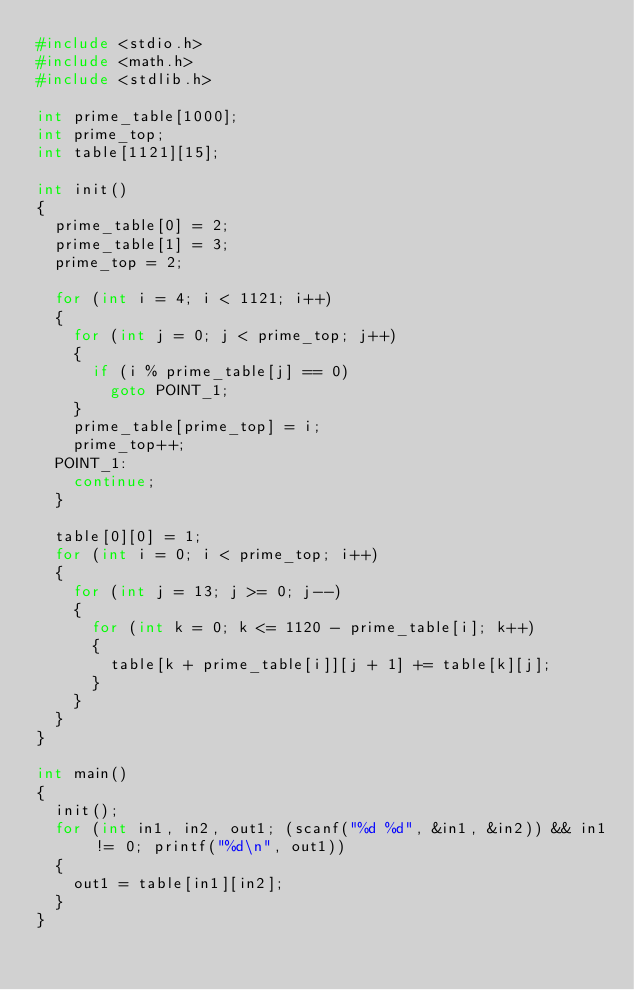Convert code to text. <code><loc_0><loc_0><loc_500><loc_500><_C_>#include <stdio.h>
#include <math.h>
#include <stdlib.h>

int prime_table[1000];
int prime_top;
int table[1121][15];

int init()
{
	prime_table[0] = 2;
	prime_table[1] = 3;
	prime_top = 2;

	for (int i = 4; i < 1121; i++)
	{
		for (int j = 0; j < prime_top; j++)
		{
			if (i % prime_table[j] == 0)
				goto POINT_1;
		}
		prime_table[prime_top] = i;
		prime_top++;
	POINT_1:
		continue;
	}

	table[0][0] = 1;
	for (int i = 0; i < prime_top; i++)
	{
		for (int j = 13; j >= 0; j--)
		{
			for (int k = 0; k <= 1120 - prime_table[i]; k++)
			{
				table[k + prime_table[i]][j + 1] += table[k][j];
			}
		}
	}
}

int main()
{
	init();
	for (int in1, in2, out1; (scanf("%d %d", &in1, &in2)) && in1 != 0; printf("%d\n", out1))
	{
		out1 = table[in1][in2];
	}
}

</code> 